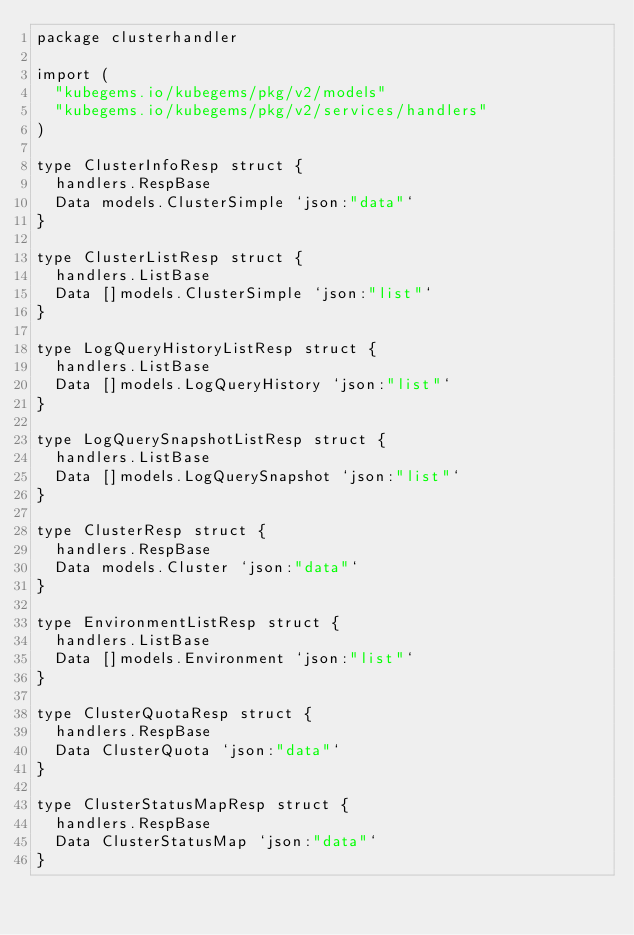Convert code to text. <code><loc_0><loc_0><loc_500><loc_500><_Go_>package clusterhandler

import (
	"kubegems.io/kubegems/pkg/v2/models"
	"kubegems.io/kubegems/pkg/v2/services/handlers"
)

type ClusterInfoResp struct {
	handlers.RespBase
	Data models.ClusterSimple `json:"data"`
}

type ClusterListResp struct {
	handlers.ListBase
	Data []models.ClusterSimple `json:"list"`
}

type LogQueryHistoryListResp struct {
	handlers.ListBase
	Data []models.LogQueryHistory `json:"list"`
}

type LogQuerySnapshotListResp struct {
	handlers.ListBase
	Data []models.LogQuerySnapshot `json:"list"`
}

type ClusterResp struct {
	handlers.RespBase
	Data models.Cluster `json:"data"`
}

type EnvironmentListResp struct {
	handlers.ListBase
	Data []models.Environment `json:"list"`
}

type ClusterQuotaResp struct {
	handlers.RespBase
	Data ClusterQuota `json:"data"`
}

type ClusterStatusMapResp struct {
	handlers.RespBase
	Data ClusterStatusMap `json:"data"`
}
</code> 